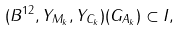<formula> <loc_0><loc_0><loc_500><loc_500>( B ^ { 1 2 } , Y _ { M _ { k } } , Y _ { C _ { k } } ) ( G _ { A _ { k } } ) \subset I ,</formula> 